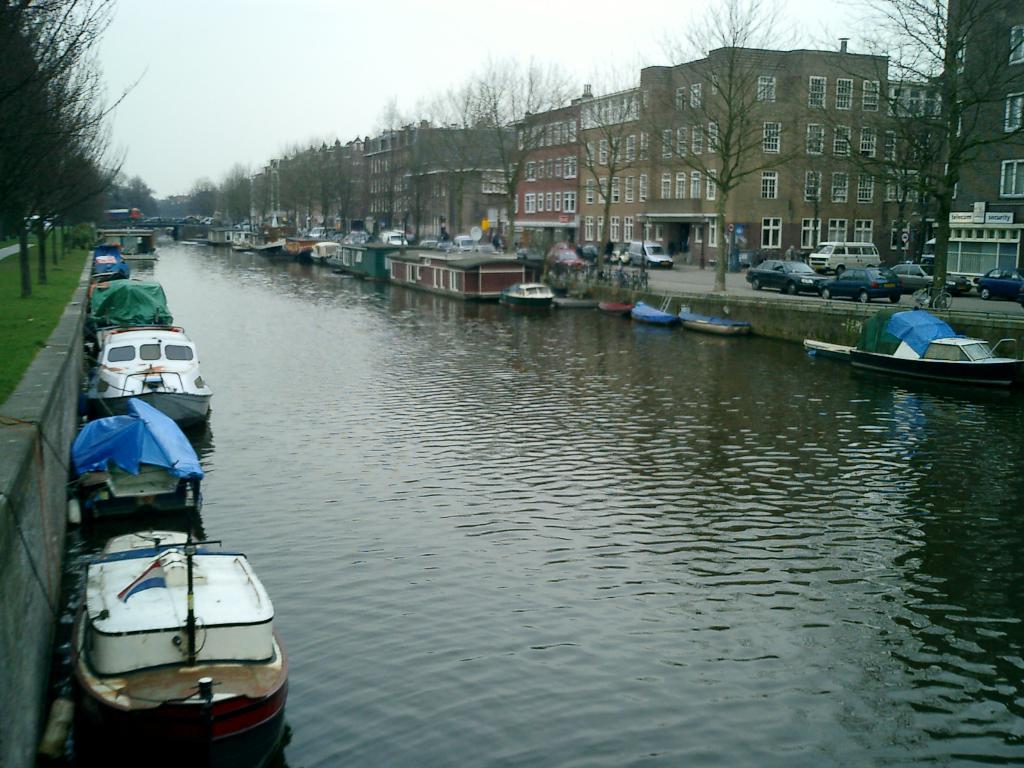What body of water is present in the image? There is a river in the image. What can be seen near the river? There are boats near the river. What structures are located around the river? There are buildings around the river. What type of vegetation is present around the river? There are trees around the river. What type of transportation is visible around the river? There are vehicles around the river. How much salt is in the river in the image? There is no information about the salt content in the river, as it is not mentioned in the provided facts. 